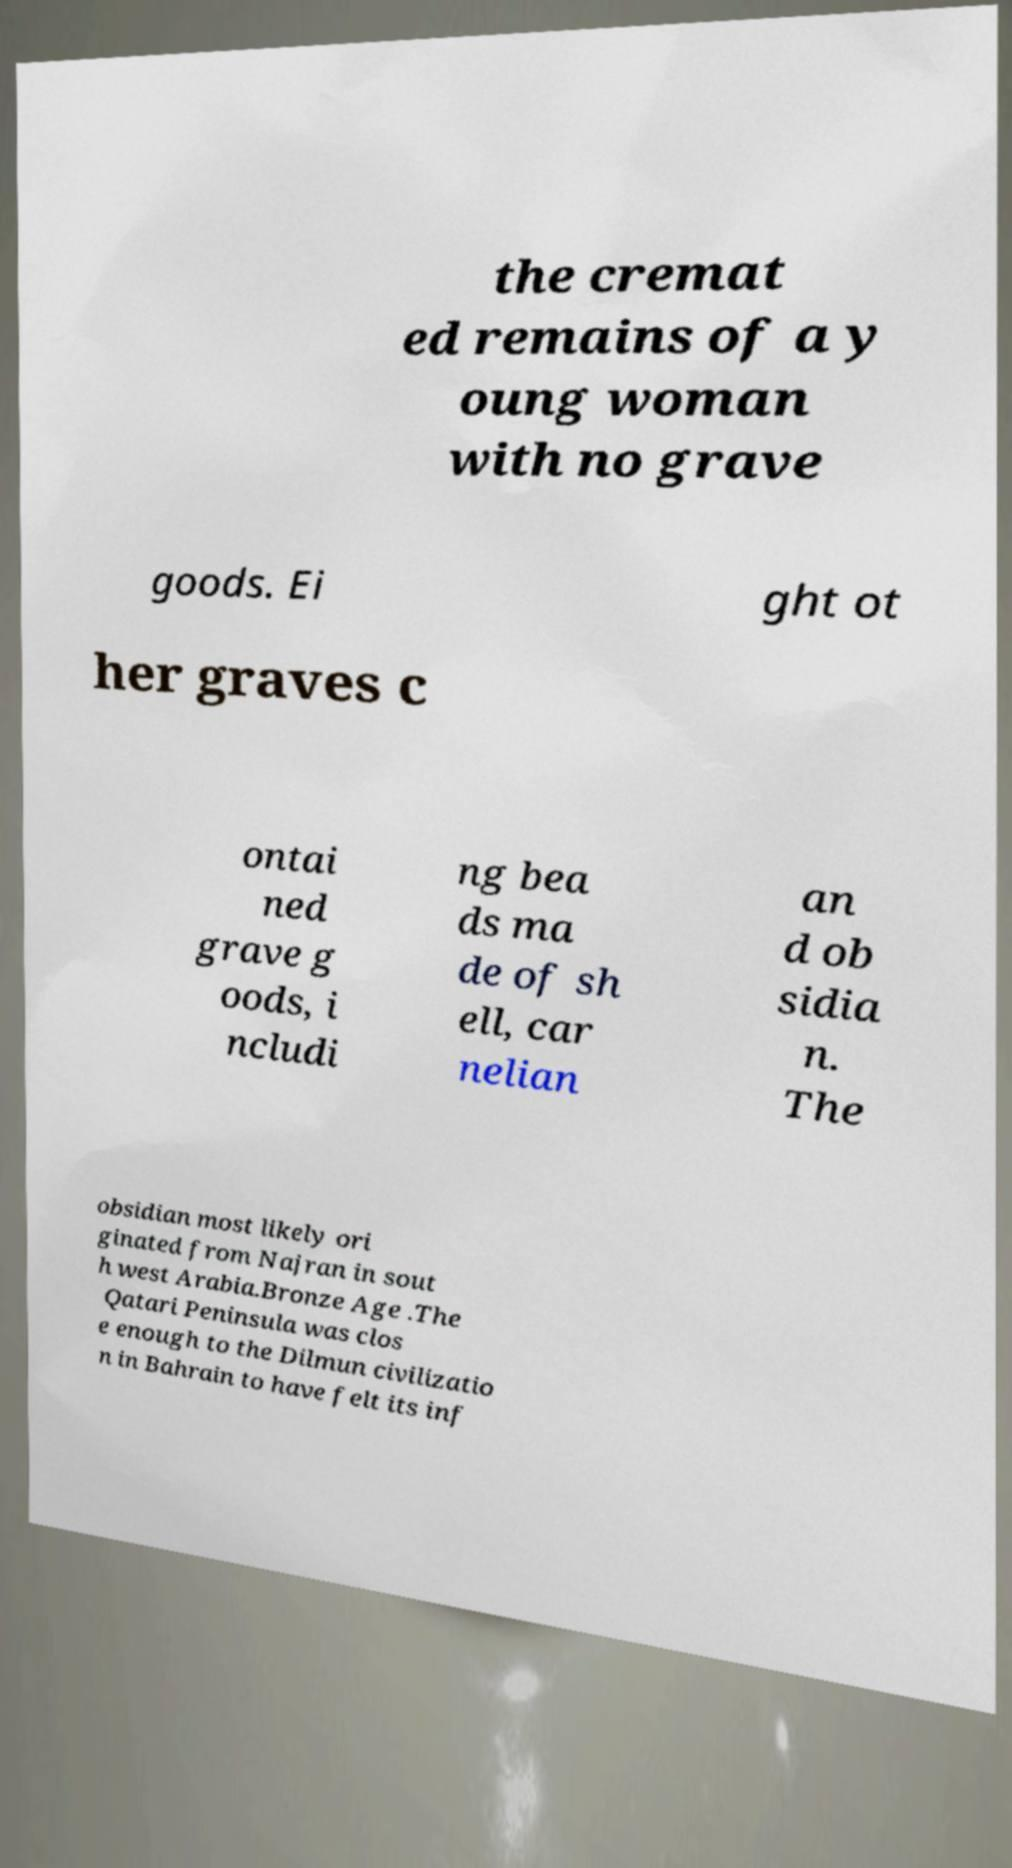Can you accurately transcribe the text from the provided image for me? the cremat ed remains of a y oung woman with no grave goods. Ei ght ot her graves c ontai ned grave g oods, i ncludi ng bea ds ma de of sh ell, car nelian an d ob sidia n. The obsidian most likely ori ginated from Najran in sout h west Arabia.Bronze Age .The Qatari Peninsula was clos e enough to the Dilmun civilizatio n in Bahrain to have felt its inf 